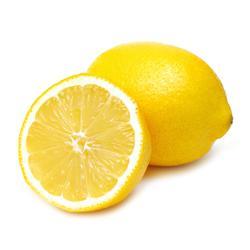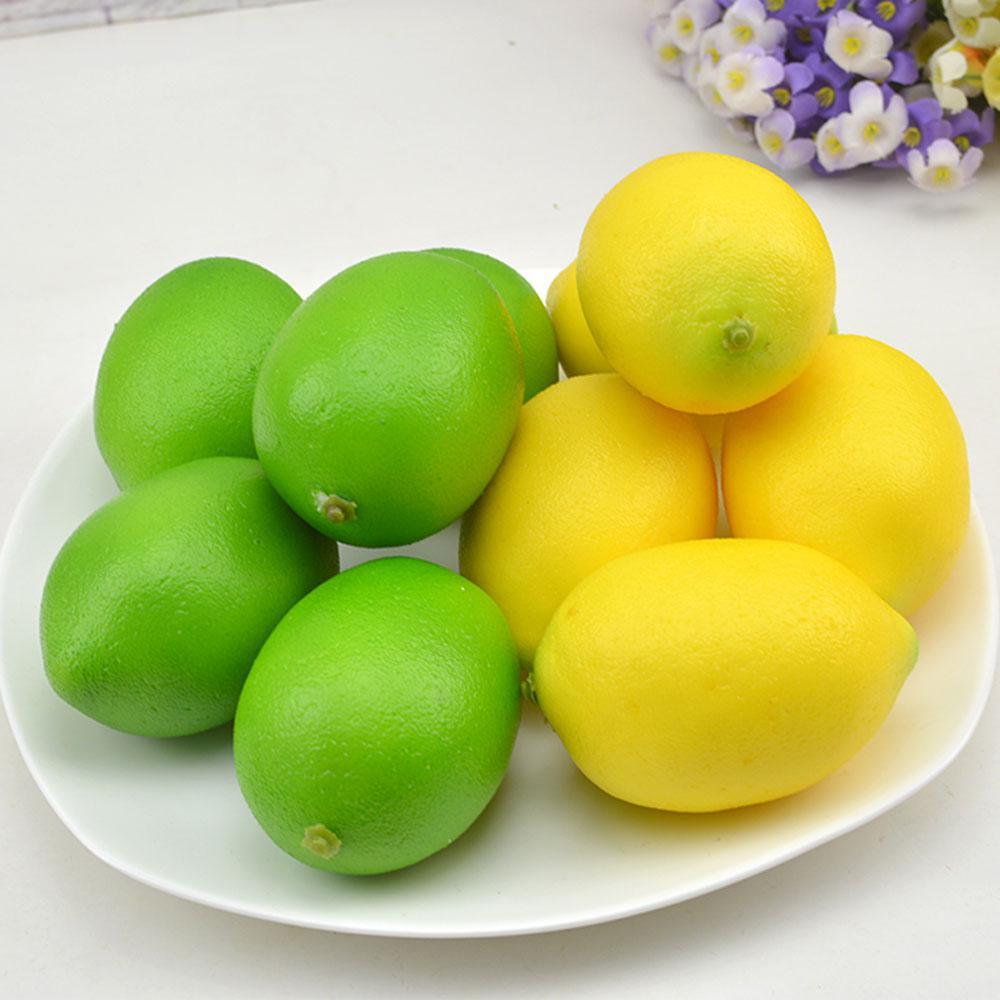The first image is the image on the left, the second image is the image on the right. Assess this claim about the two images: "There is a sliced lemon in exactly one image.". Correct or not? Answer yes or no. Yes. 